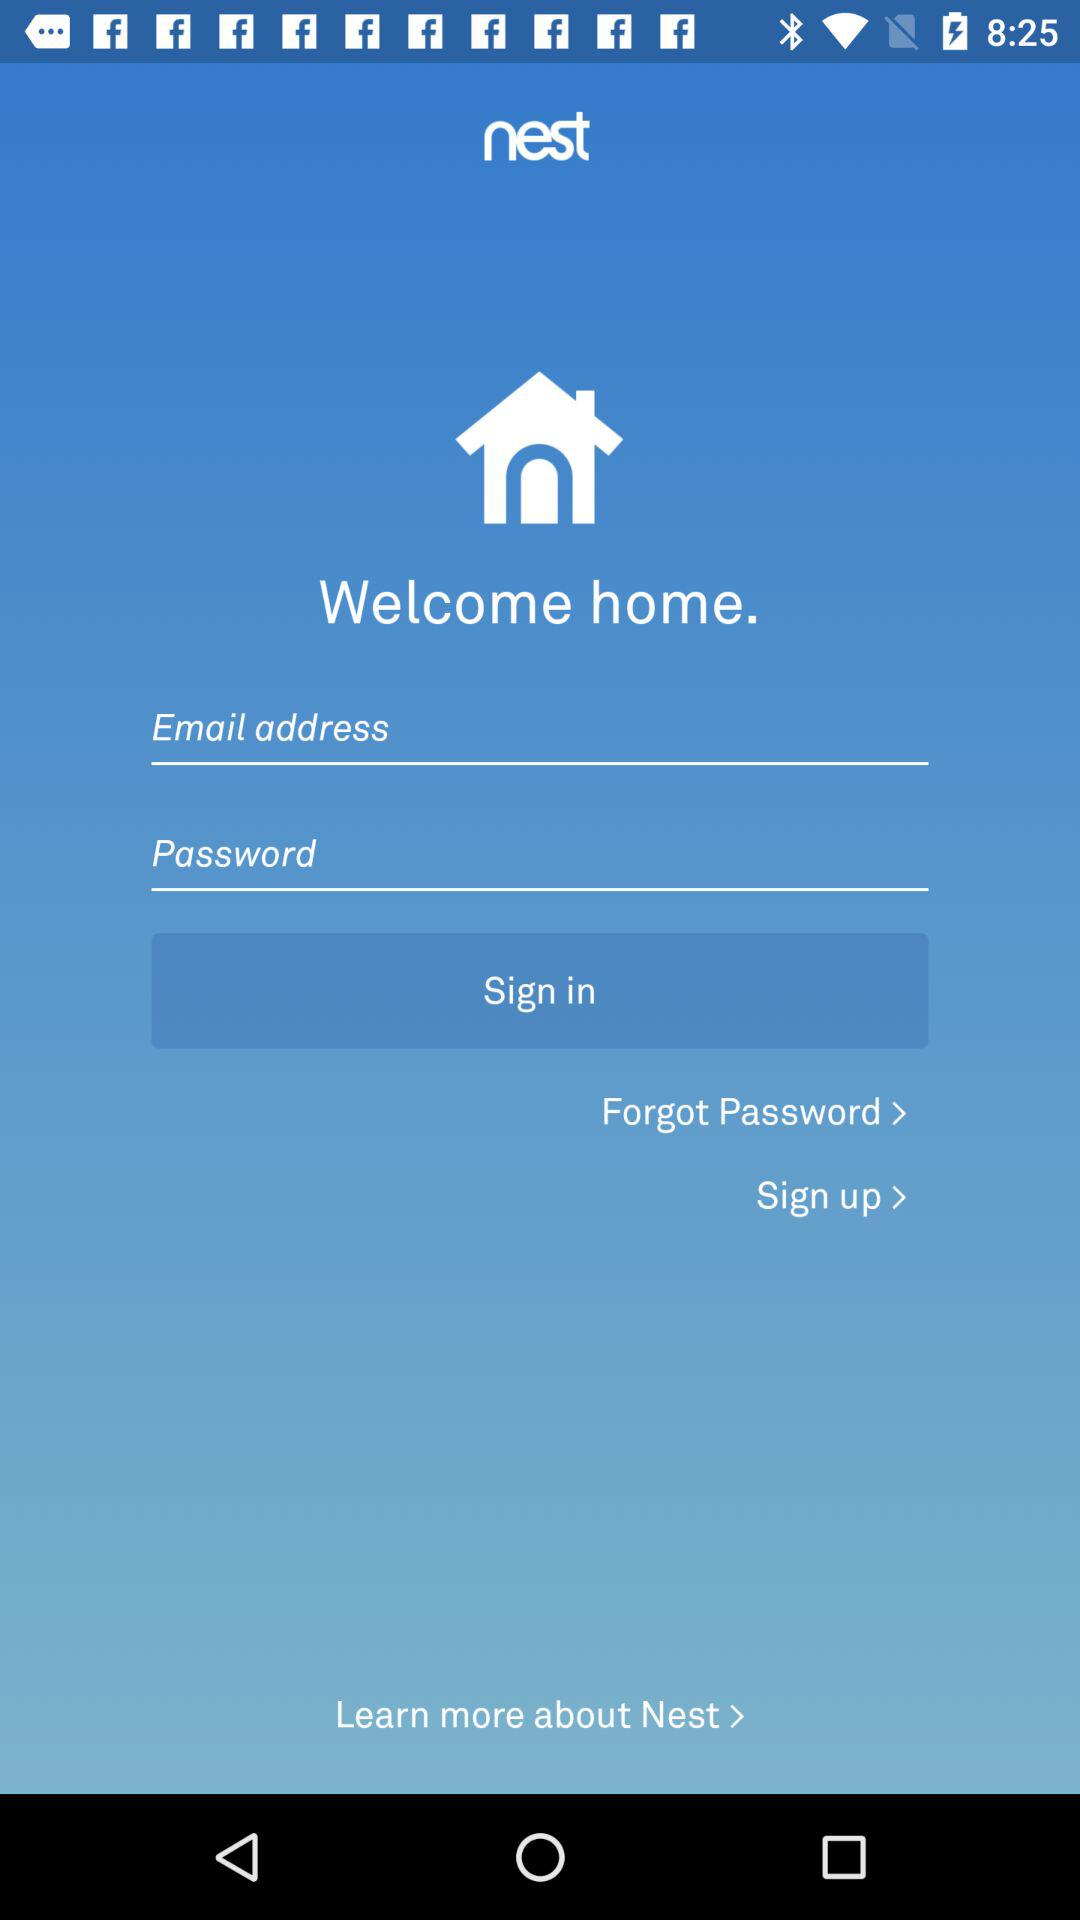Where do I go to learn more about "Nest"?
When the provided information is insufficient, respond with <no answer>. <no answer> 